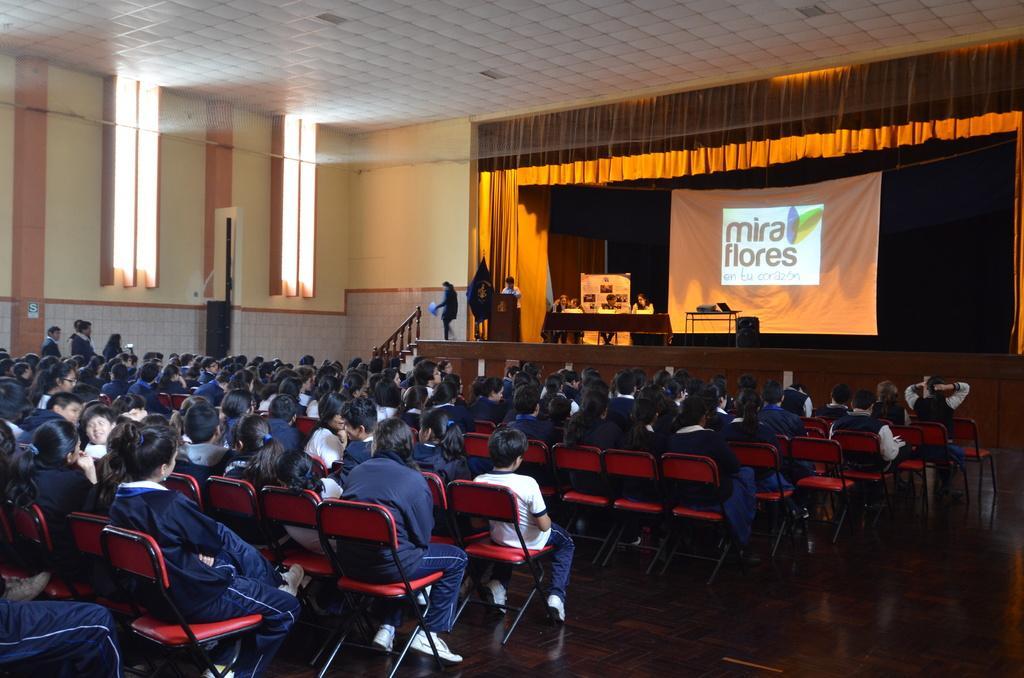Could you give a brief overview of what you see in this image? In this image a big hall is there and many students are sitting on the chair and wearing the blue pant and shirt and on the stage some people are sitting on the chair behind the person some poster are there in the background is very cloudy. 